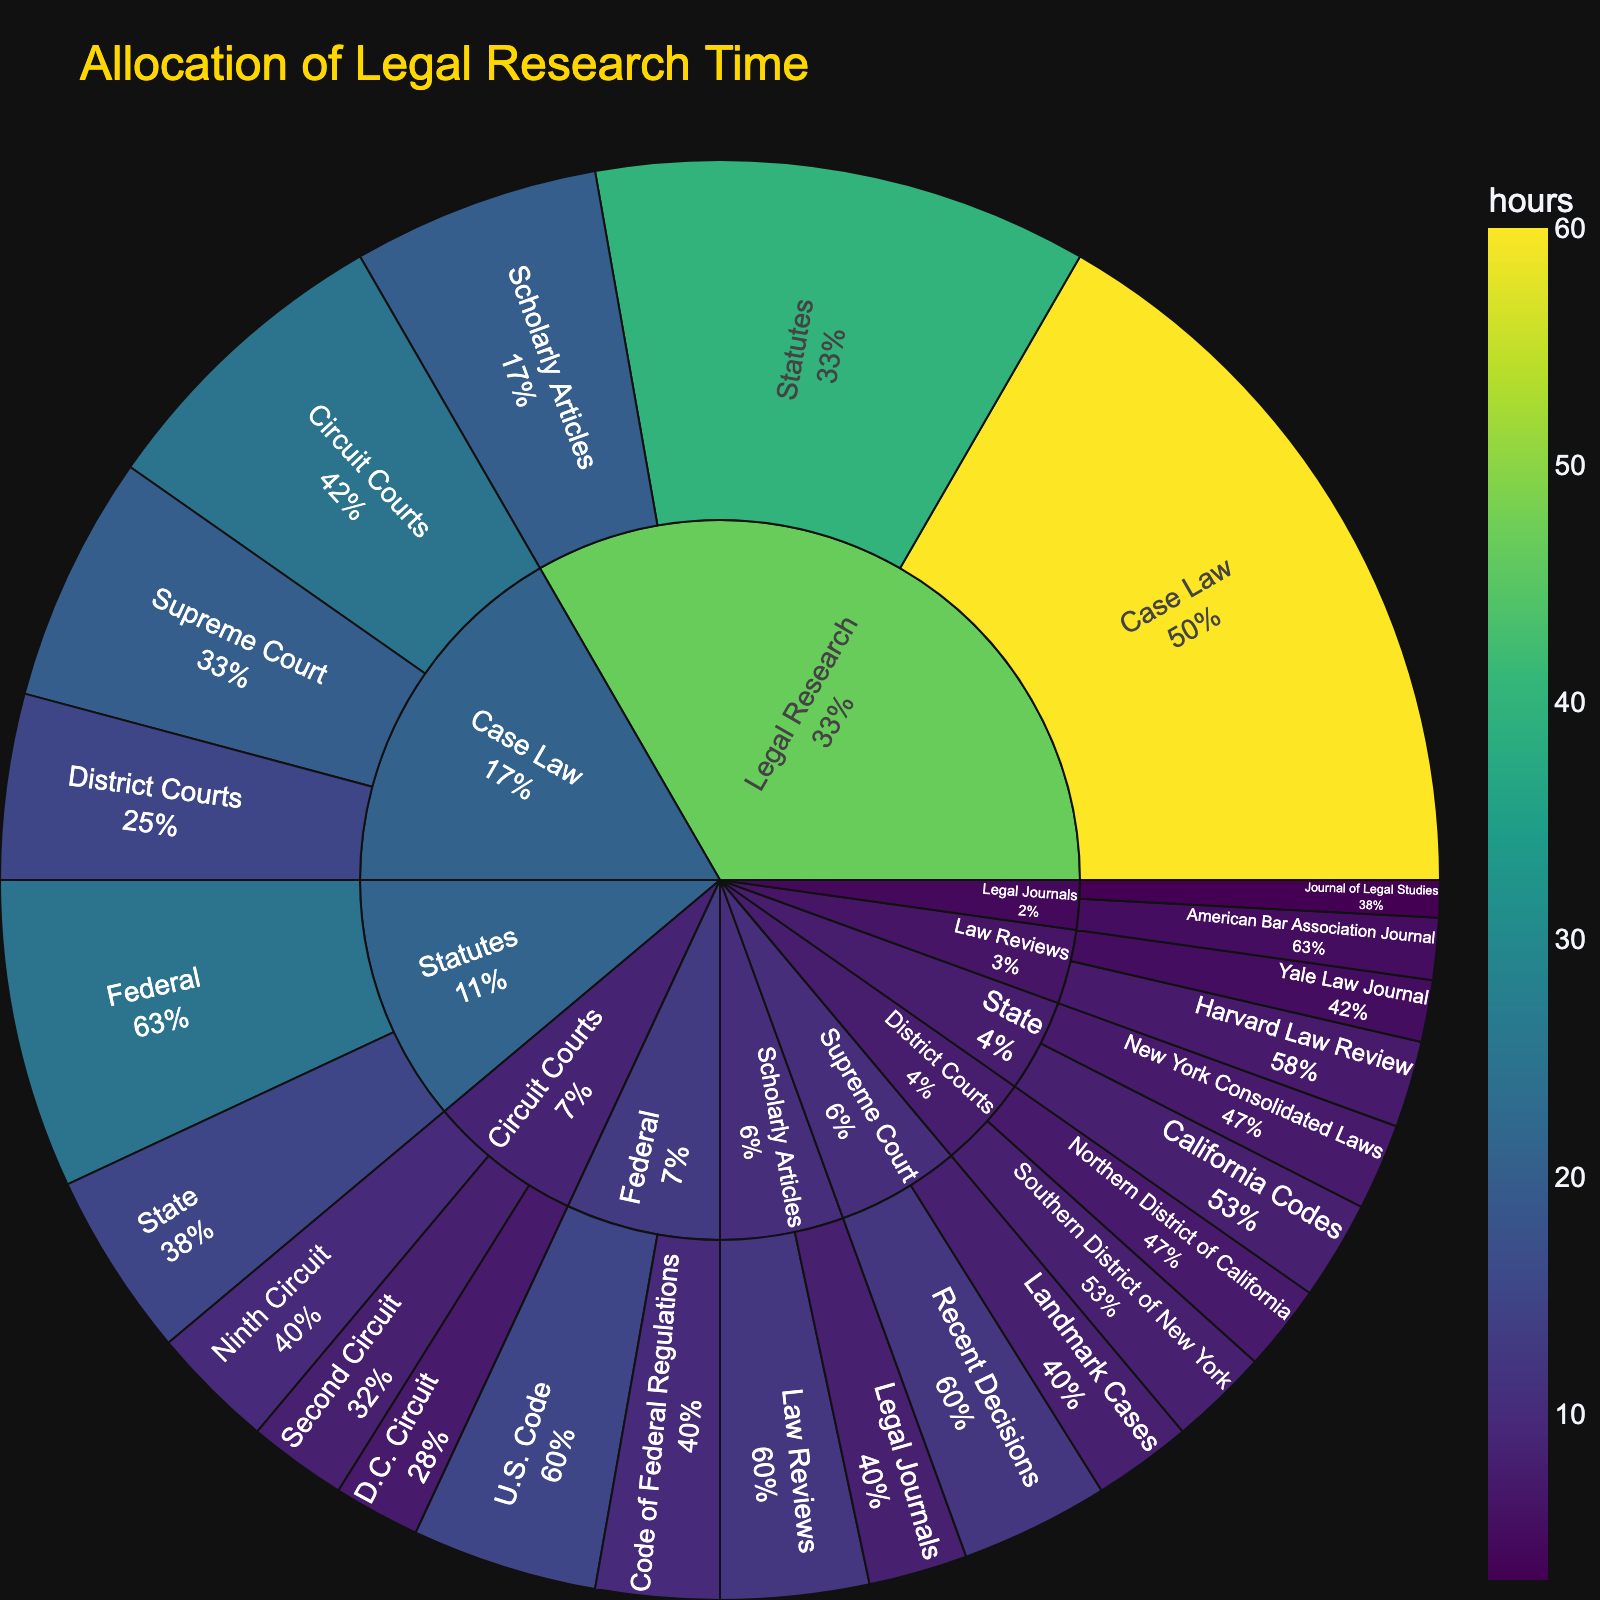What is the title of the Sunburst Plot? The title is prominently displayed at the top of the figure and usually in a larger, distinct font size. We can clearly see this text at the top of the plot.
Answer: Allocation of Legal Research Time How much time is spent on legal research overall? We need to add up the hours spent on all subcategories within "Legal Research" which are "Statutes", "Case Law", and "Scholarly Articles". From the data:
Statutes: 40 hours
Case Law: 60 hours
Scholarly Articles: 20 hours 
Total = 40 + 60 + 20
Answer: 120 hours Which type of legal source utilizes the most research time? By observing the size and color intensity of the sections in the sunburst plot, we see that "Case Law" has the largest section with the highest number of hours, which indicates intensive legal research.
Answer: Case Law Percentage-wise, how much time is spent on Federal vs. State statutes? Calculate the percentage of time spent on each type of statute:
Federal: 25 hours
State: 15 hours
Total for Statutes = 25 + 15 = 40 hours
Percentage for Federal = (25/40) * 100%
Percentage for State = (15/40) * 100%
Answer: Federal: 62.5%, State: 37.5% How many more hours are spent on Circuit Courts compared to District Courts? From the figure, Circuit Courts get 25 hours and District Courts get 15 hours. Calculate the difference:
25 (Circuit Courts) - 15 (District Courts) = 10 hours
Answer: 10 hours Which specific Circuit Court utilizes the least amount of research time? By looking at the divisions of "Circuit Courts", we see that D.C. Circuit receives the least attention at 7 hours.
Answer: D.C. Circuit How do the hours spent on "California Codes" compare to those spent on "New York Consolidated Laws"? From the data, "California Codes" get 8 hours and "New York Consolidated Laws" get 7 hours. 
Comparison 8 hours (California Codes) > 7 hours (New York Consolidated Laws)
Answer: California Codes What is the proportion of research time allocated to Law Reviews within the Scholarly Articles category? Total hours for Scholarly Articles is 20. 
For Law Reviews within Scholarly Articles, the time is 12 hours.
Proportion = (12/20) * 100%
Answer: 60% What's the combined time spent researching Harvard Law Review and Yale Law Journal? Look at the sub-divisions under "Law Reviews":
Harvard Law Review: 7 hours
Yale Law Journal: 5 hours
Combined time = 7 + 5
Answer: 12 hours In the category of Case Law, what percentage of research time is dedicated to Supreme Court cases? Total time spent on Case Law is 60 hours.
Supreme Court time: Recent Decisions (12) + Landmark Cases (8) = 20 hours
Percentage = (20/60) * 100%
Answer: 33.33% 